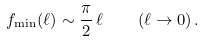Convert formula to latex. <formula><loc_0><loc_0><loc_500><loc_500>f _ { \min } ( \ell ) \sim \frac { \pi } { 2 } \, \ell \quad ( \ell \to 0 ) \, .</formula> 